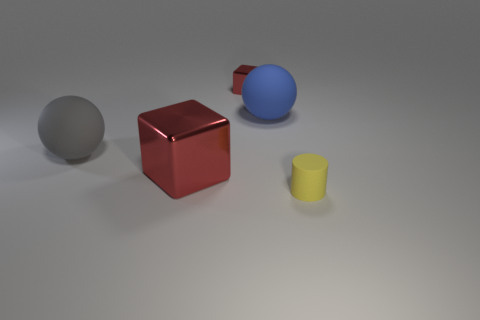Are there more big gray rubber things that are behind the big blue thing than blue objects that are behind the small metal object?
Make the answer very short. No. What number of rubber objects are either tiny red blocks or big blue balls?
Provide a succinct answer. 1. There is a blue sphere that is to the right of the small metallic object; what material is it?
Give a very brief answer. Rubber. How many things are big blue blocks or objects in front of the blue object?
Provide a succinct answer. 3. There is a gray matte thing that is the same size as the blue object; what shape is it?
Your response must be concise. Sphere. What number of balls have the same color as the small cylinder?
Keep it short and to the point. 0. Are the small thing to the right of the blue rubber thing and the big cube made of the same material?
Ensure brevity in your answer.  No. There is a blue matte object; what shape is it?
Provide a succinct answer. Sphere. How many yellow things are large cubes or small metallic objects?
Your answer should be very brief. 0. How many other objects are the same material as the small yellow cylinder?
Give a very brief answer. 2. 